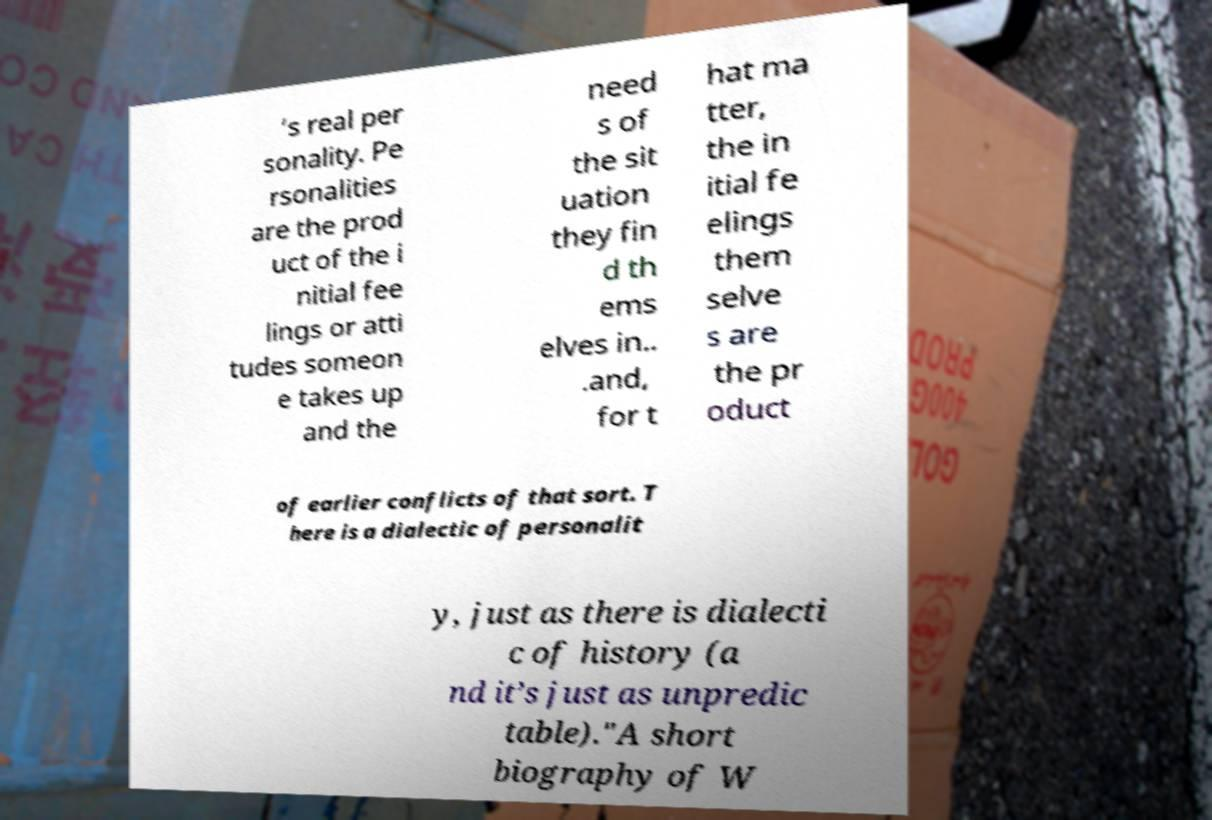Please read and relay the text visible in this image. What does it say? ’s real per sonality. Pe rsonalities are the prod uct of the i nitial fee lings or atti tudes someon e takes up and the need s of the sit uation they fin d th ems elves in.. .and, for t hat ma tter, the in itial fe elings them selve s are the pr oduct of earlier conflicts of that sort. T here is a dialectic of personalit y, just as there is dialecti c of history (a nd it’s just as unpredic table)."A short biography of W 